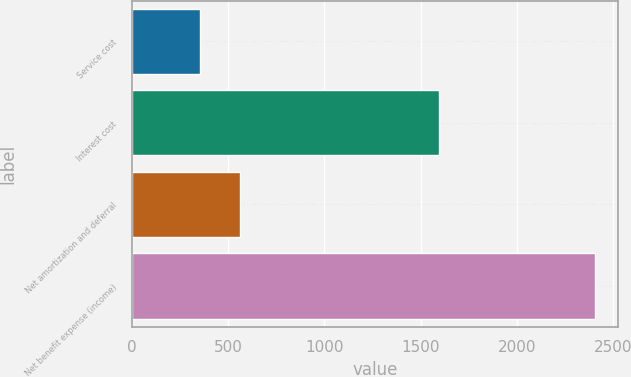<chart> <loc_0><loc_0><loc_500><loc_500><bar_chart><fcel>Service cost<fcel>Interest cost<fcel>Net amortization and deferral<fcel>Net benefit expense (income)<nl><fcel>355<fcel>1595<fcel>559.9<fcel>2404<nl></chart> 